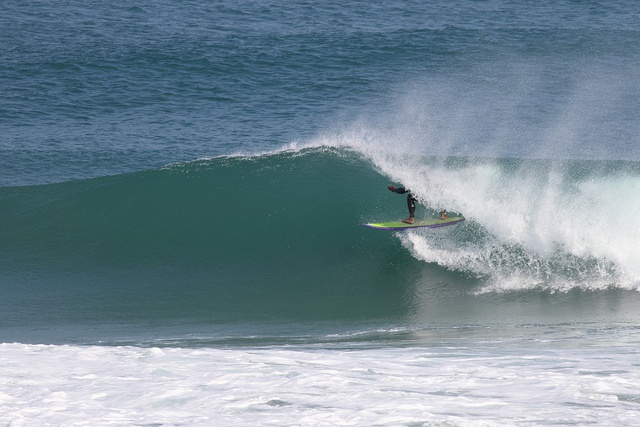Describe the objects in this image and their specific colors. I can see surfboard in blue, olive, gray, and darkgray tones and people in blue, black, gray, and teal tones in this image. 